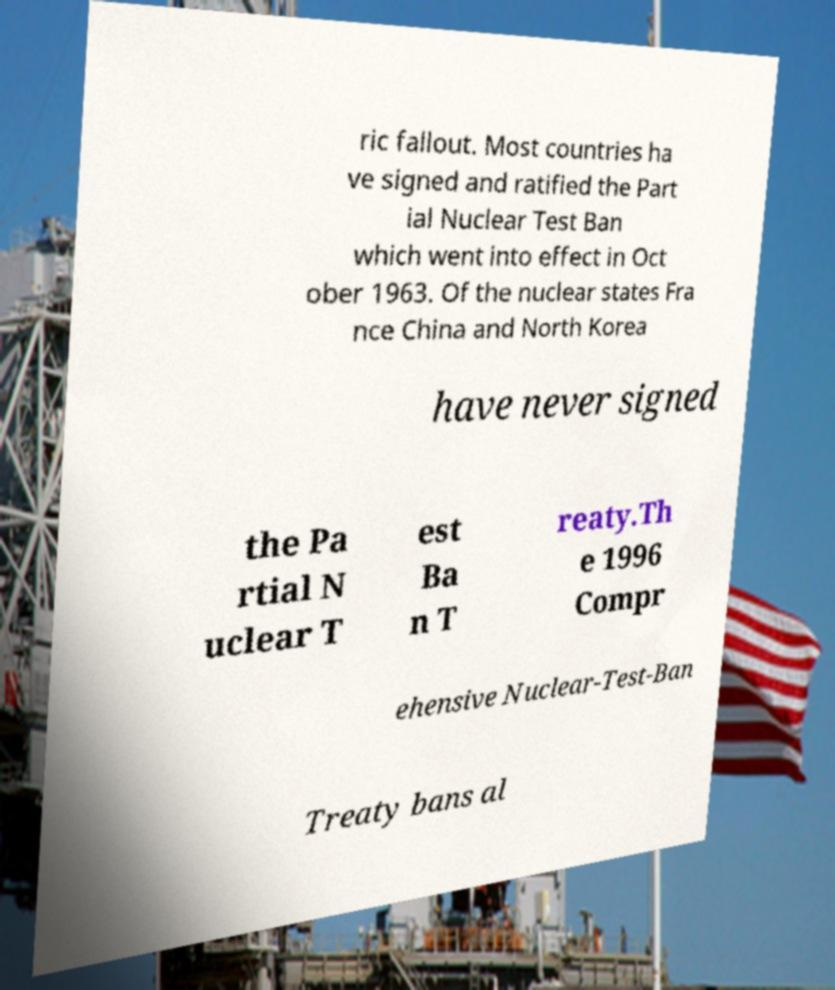Please read and relay the text visible in this image. What does it say? ric fallout. Most countries ha ve signed and ratified the Part ial Nuclear Test Ban which went into effect in Oct ober 1963. Of the nuclear states Fra nce China and North Korea have never signed the Pa rtial N uclear T est Ba n T reaty.Th e 1996 Compr ehensive Nuclear-Test-Ban Treaty bans al 